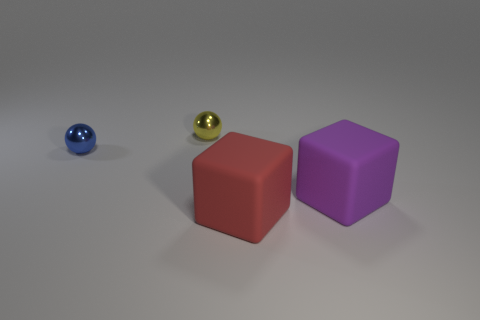There is a metal thing that is the same size as the blue ball; what is its color? yellow 